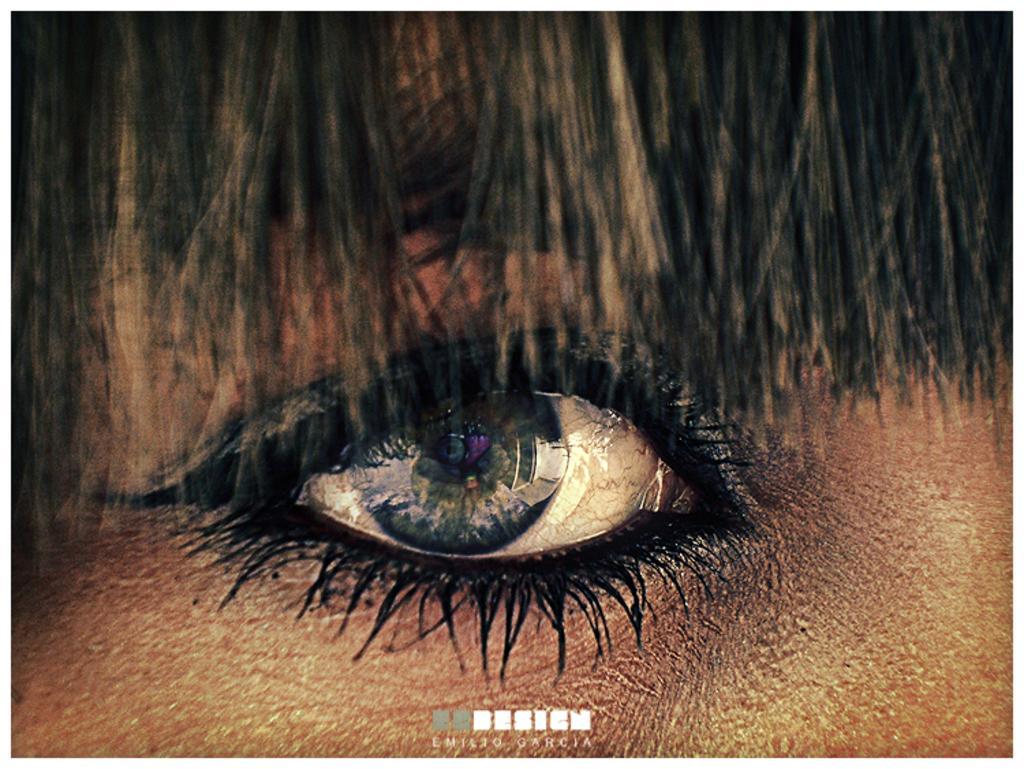Can you describe this image briefly? In the picture we can see a eye of a person on the top of it we can see hairs which are black in color. 